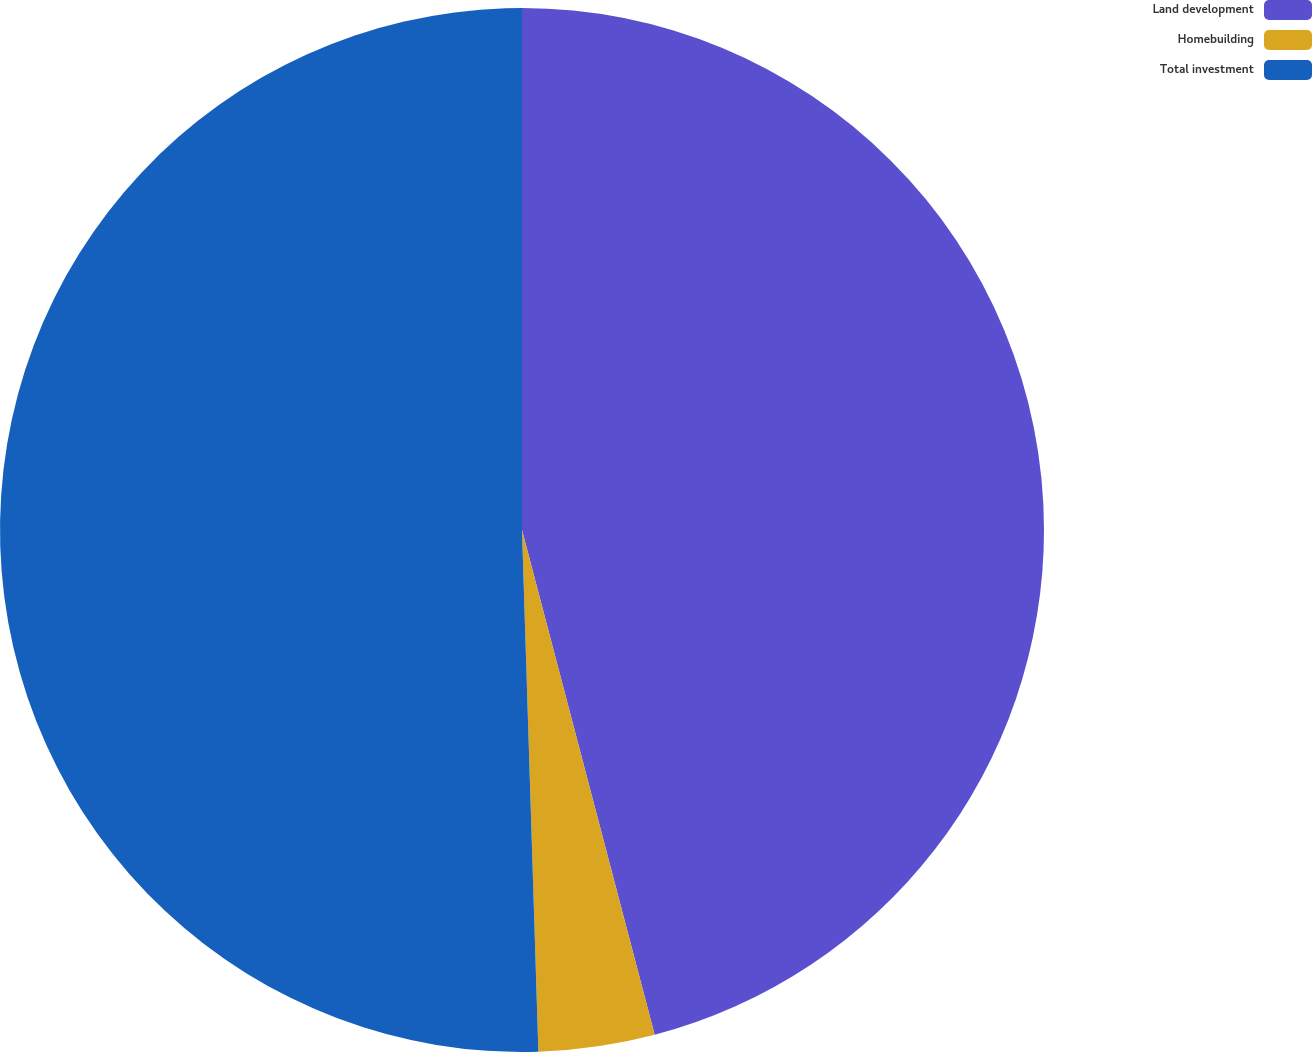Convert chart to OTSL. <chart><loc_0><loc_0><loc_500><loc_500><pie_chart><fcel>Land development<fcel>Homebuilding<fcel>Total investment<nl><fcel>45.91%<fcel>3.59%<fcel>50.5%<nl></chart> 